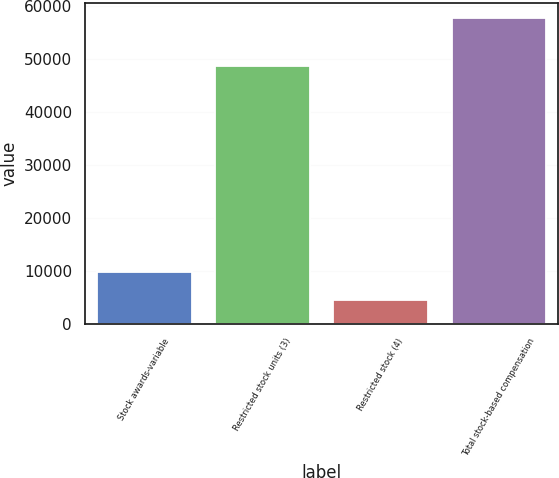Convert chart. <chart><loc_0><loc_0><loc_500><loc_500><bar_chart><fcel>Stock awards-variable<fcel>Restricted stock units (3)<fcel>Restricted stock (4)<fcel>Total stock-based compensation<nl><fcel>9820.2<fcel>48625<fcel>4500<fcel>57702<nl></chart> 